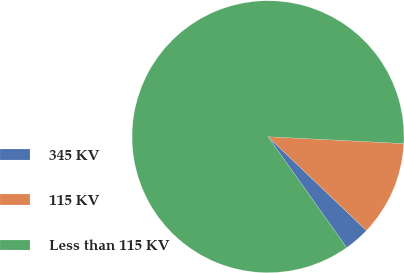<chart> <loc_0><loc_0><loc_500><loc_500><pie_chart><fcel>345 KV<fcel>115 KV<fcel>Less than 115 KV<nl><fcel>3.06%<fcel>11.32%<fcel>85.62%<nl></chart> 